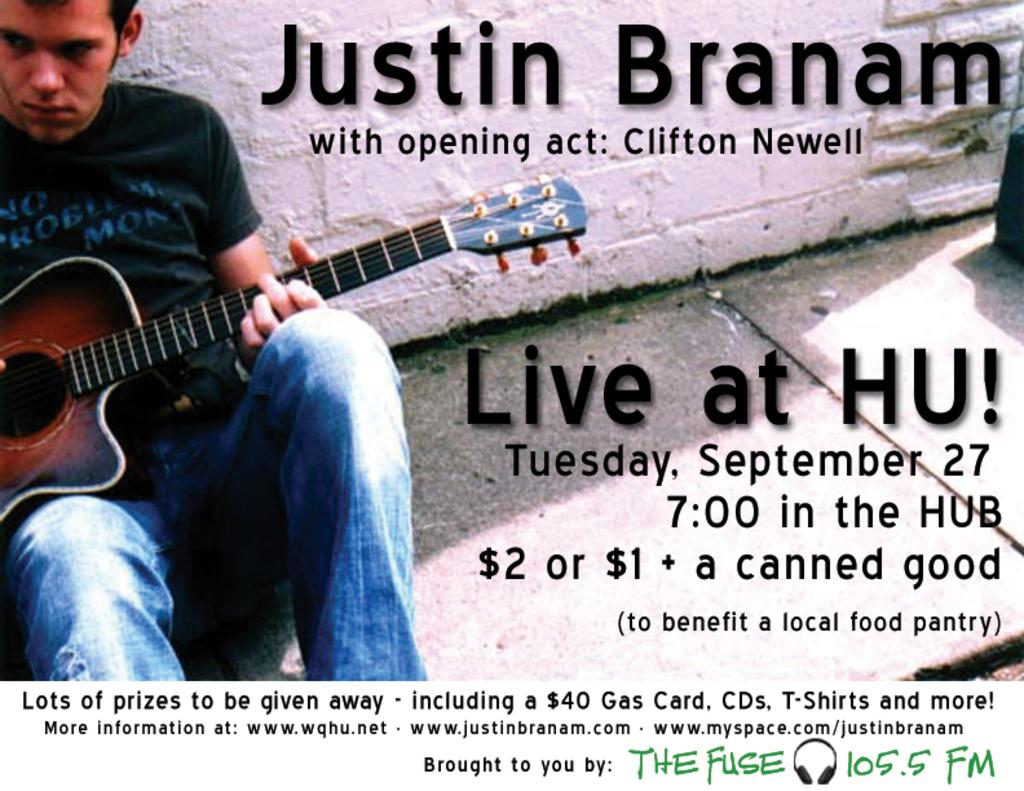What is the man in the image doing? The man is playing a guitar. What is the man wearing on his upper body? The man is wearing a black t-shirt. What is the man wearing on his lower body? The man is wearing blue jeans. Is there a lamp in the image? There is no lamp present in the image. Is the man playing the guitar in the snow? There is no snow present in the image, and the man is not playing the guitar in the snow. 